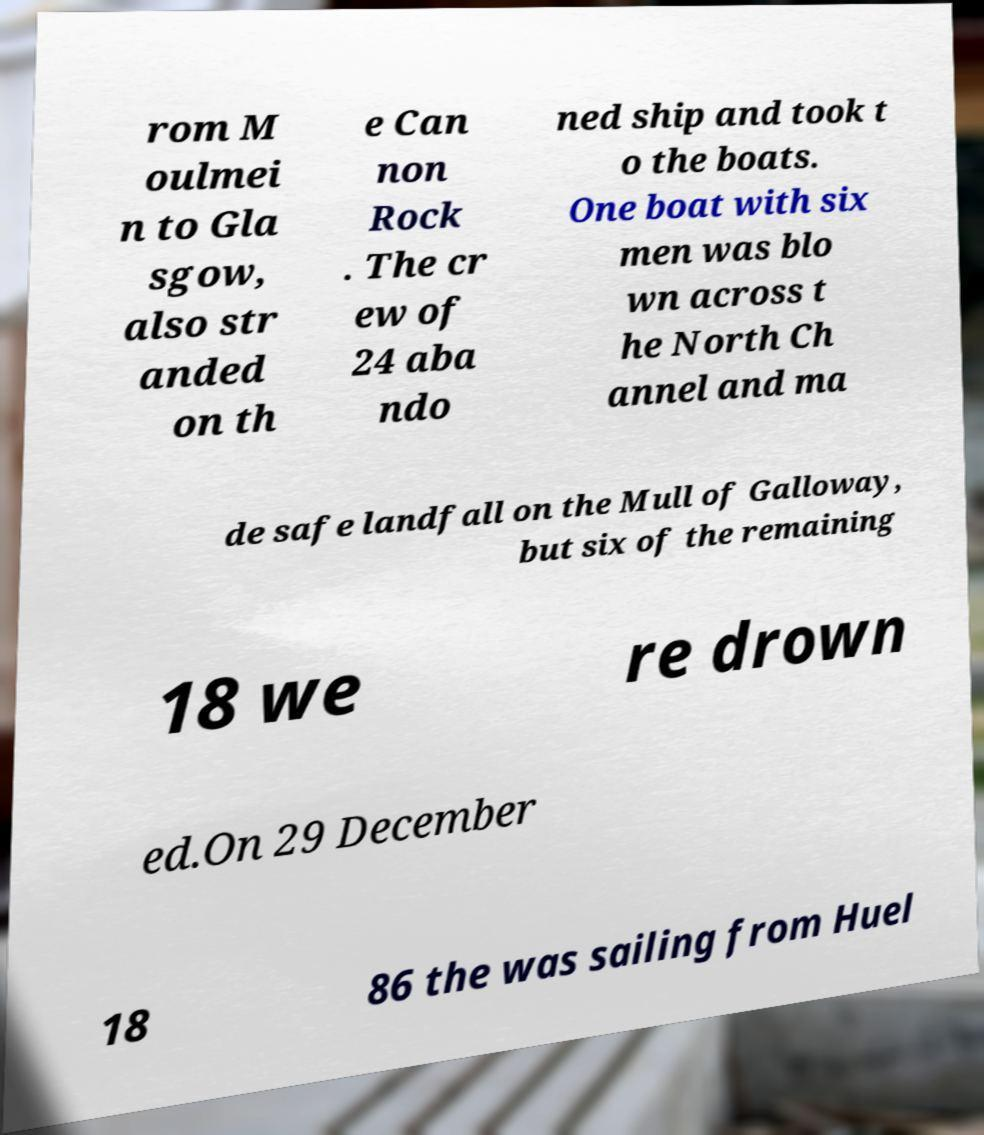What messages or text are displayed in this image? I need them in a readable, typed format. rom M oulmei n to Gla sgow, also str anded on th e Can non Rock . The cr ew of 24 aba ndo ned ship and took t o the boats. One boat with six men was blo wn across t he North Ch annel and ma de safe landfall on the Mull of Galloway, but six of the remaining 18 we re drown ed.On 29 December 18 86 the was sailing from Huel 